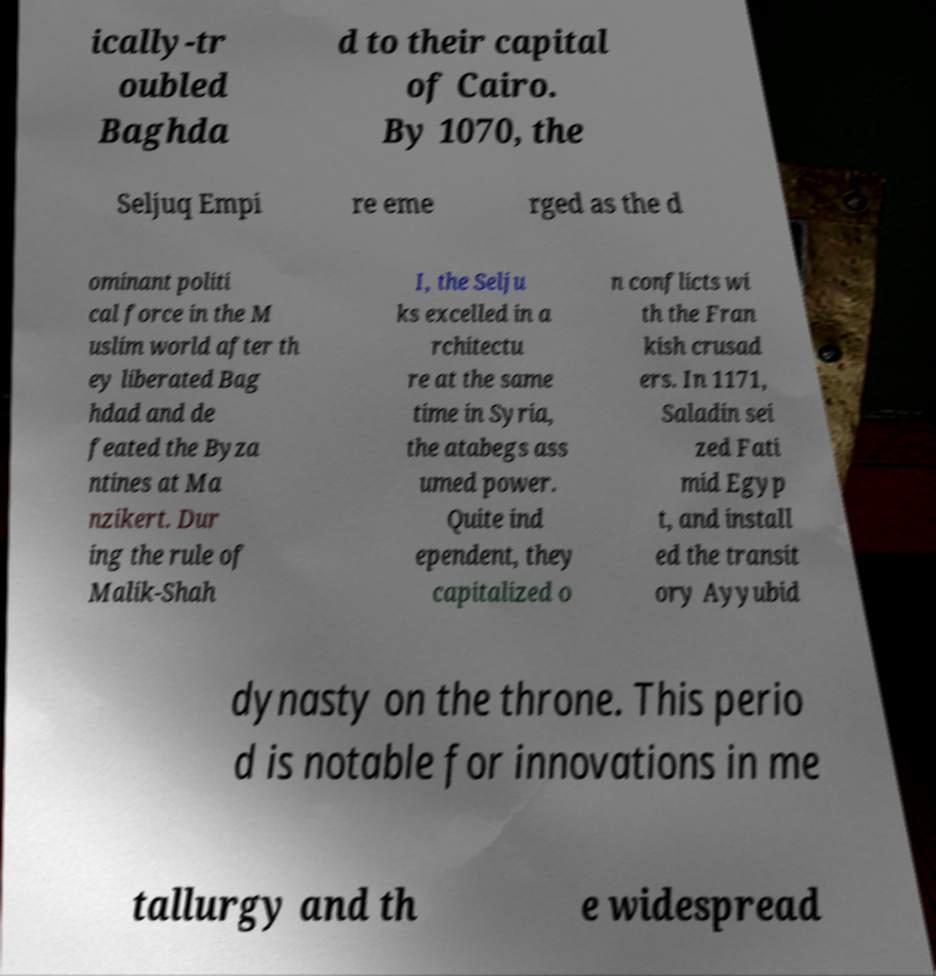Could you extract and type out the text from this image? ically-tr oubled Baghda d to their capital of Cairo. By 1070, the Seljuq Empi re eme rged as the d ominant politi cal force in the M uslim world after th ey liberated Bag hdad and de feated the Byza ntines at Ma nzikert. Dur ing the rule of Malik-Shah I, the Selju ks excelled in a rchitectu re at the same time in Syria, the atabegs ass umed power. Quite ind ependent, they capitalized o n conflicts wi th the Fran kish crusad ers. In 1171, Saladin sei zed Fati mid Egyp t, and install ed the transit ory Ayyubid dynasty on the throne. This perio d is notable for innovations in me tallurgy and th e widespread 